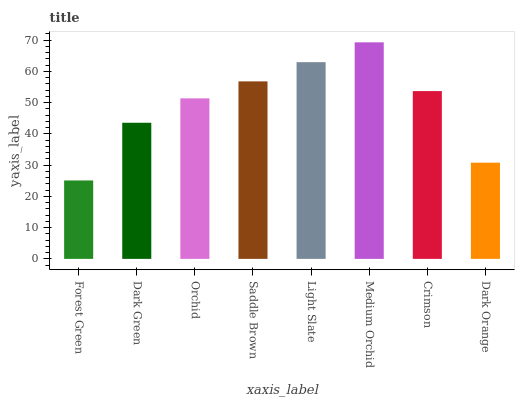Is Dark Green the minimum?
Answer yes or no. No. Is Dark Green the maximum?
Answer yes or no. No. Is Dark Green greater than Forest Green?
Answer yes or no. Yes. Is Forest Green less than Dark Green?
Answer yes or no. Yes. Is Forest Green greater than Dark Green?
Answer yes or no. No. Is Dark Green less than Forest Green?
Answer yes or no. No. Is Crimson the high median?
Answer yes or no. Yes. Is Orchid the low median?
Answer yes or no. Yes. Is Dark Orange the high median?
Answer yes or no. No. Is Light Slate the low median?
Answer yes or no. No. 